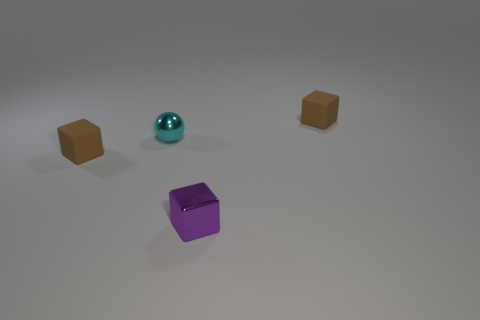Subtract all brown blocks. How many blocks are left? 1 Add 4 yellow cylinders. How many objects exist? 8 Subtract all purple blocks. How many blocks are left? 2 Subtract 2 blocks. How many blocks are left? 1 Subtract all spheres. How many objects are left? 3 Subtract all red balls. How many brown blocks are left? 2 Subtract all tiny things. Subtract all tiny cyan cylinders. How many objects are left? 0 Add 3 small purple metallic objects. How many small purple metallic objects are left? 4 Add 3 tiny red matte things. How many tiny red matte things exist? 3 Subtract 0 yellow cubes. How many objects are left? 4 